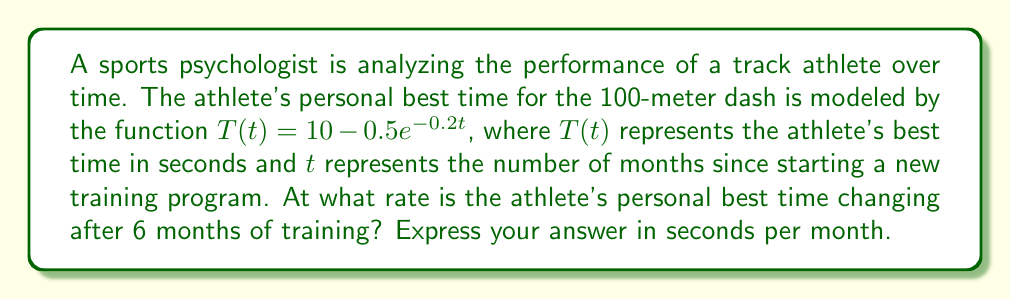Can you solve this math problem? To solve this problem, we need to find the rate of change of the athlete's personal best time after 6 months. This can be done by evaluating the derivative of the function $T(t)$ at $t=6$.

1) First, let's find the derivative of $T(t)$:
   $$\frac{dT}{dt} = \frac{d}{dt}[10 - 0.5e^{-0.2t}] = -0.5 \cdot (-0.2)e^{-0.2t} = 0.1e^{-0.2t}$$

2) Now, we evaluate this derivative at $t=6$:
   $$\left.\frac{dT}{dt}\right|_{t=6} = 0.1e^{-0.2(6)} = 0.1e^{-1.2}$$

3) To calculate this value:
   $$0.1e^{-1.2} \approx 0.1 \cdot 0.301194 \approx 0.0301194$$

The negative sign of this result indicates that the time is decreasing (improving) as months pass.

It's important to note that while this mathematical model shows continuous improvement, in reality, athletic performance is influenced by many factors and may not follow such a smooth curve. The sports psychologist might interpret this result as an interesting data point but would likely emphasize that the athlete's true progress and achievement cannot be fully captured by numbers alone.
Answer: The athlete's personal best time is changing at a rate of approximately -0.0301194 seconds per month after 6 months of training. 